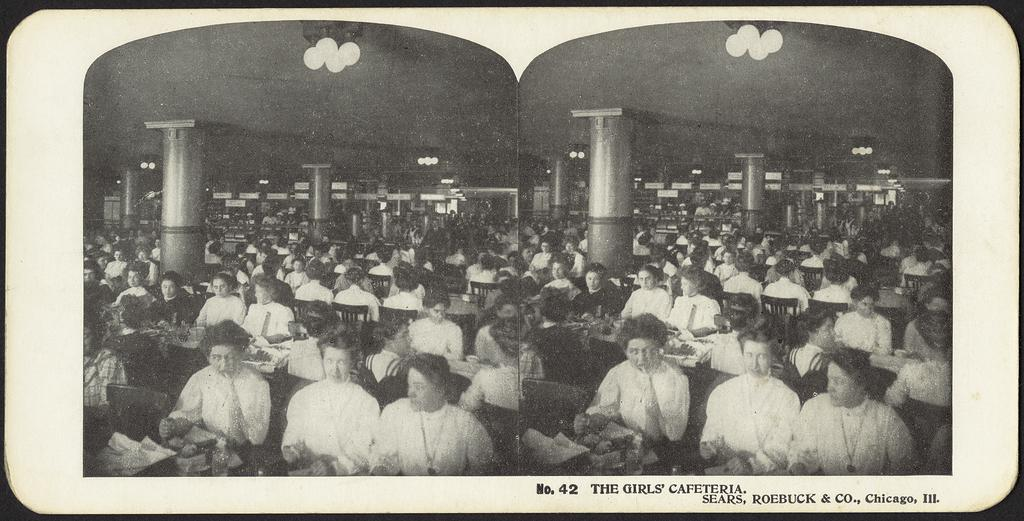What are the people in the image doing? There is a group of persons sitting in the image. Is there any text visible in the image? Yes, there is text written at the bottom right of the image. What can be seen hanging from the roof in the image? There are lights hanging on the roof in the image. What architectural features are present in the image? There are pillars in the image. What type of yarn is being used by the authority figure in the image? There is no authority figure or yarn present in the image. What class of students is depicted in the image? The image does not depict a class or students; it shows a group of persons sitting. 